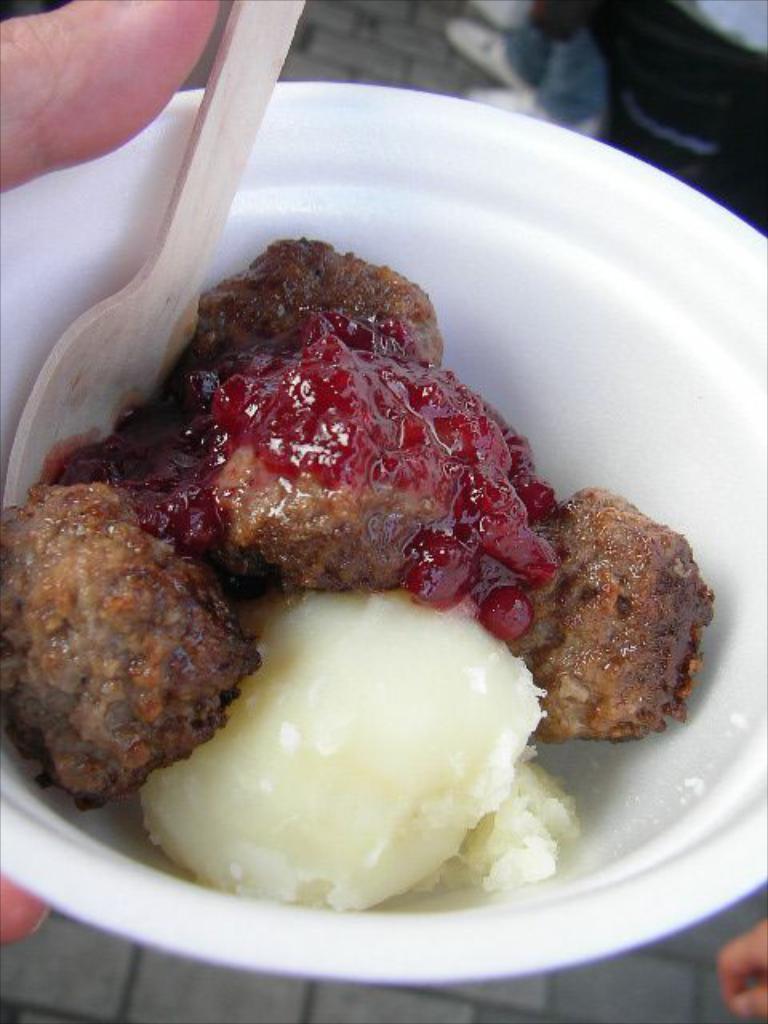Please provide a concise description of this image. In this image I can see a person is holding a white colored bowel and in the bowl I can see a food item which is brown, red and cream in color. In the background I can see persons legs and the ground. 